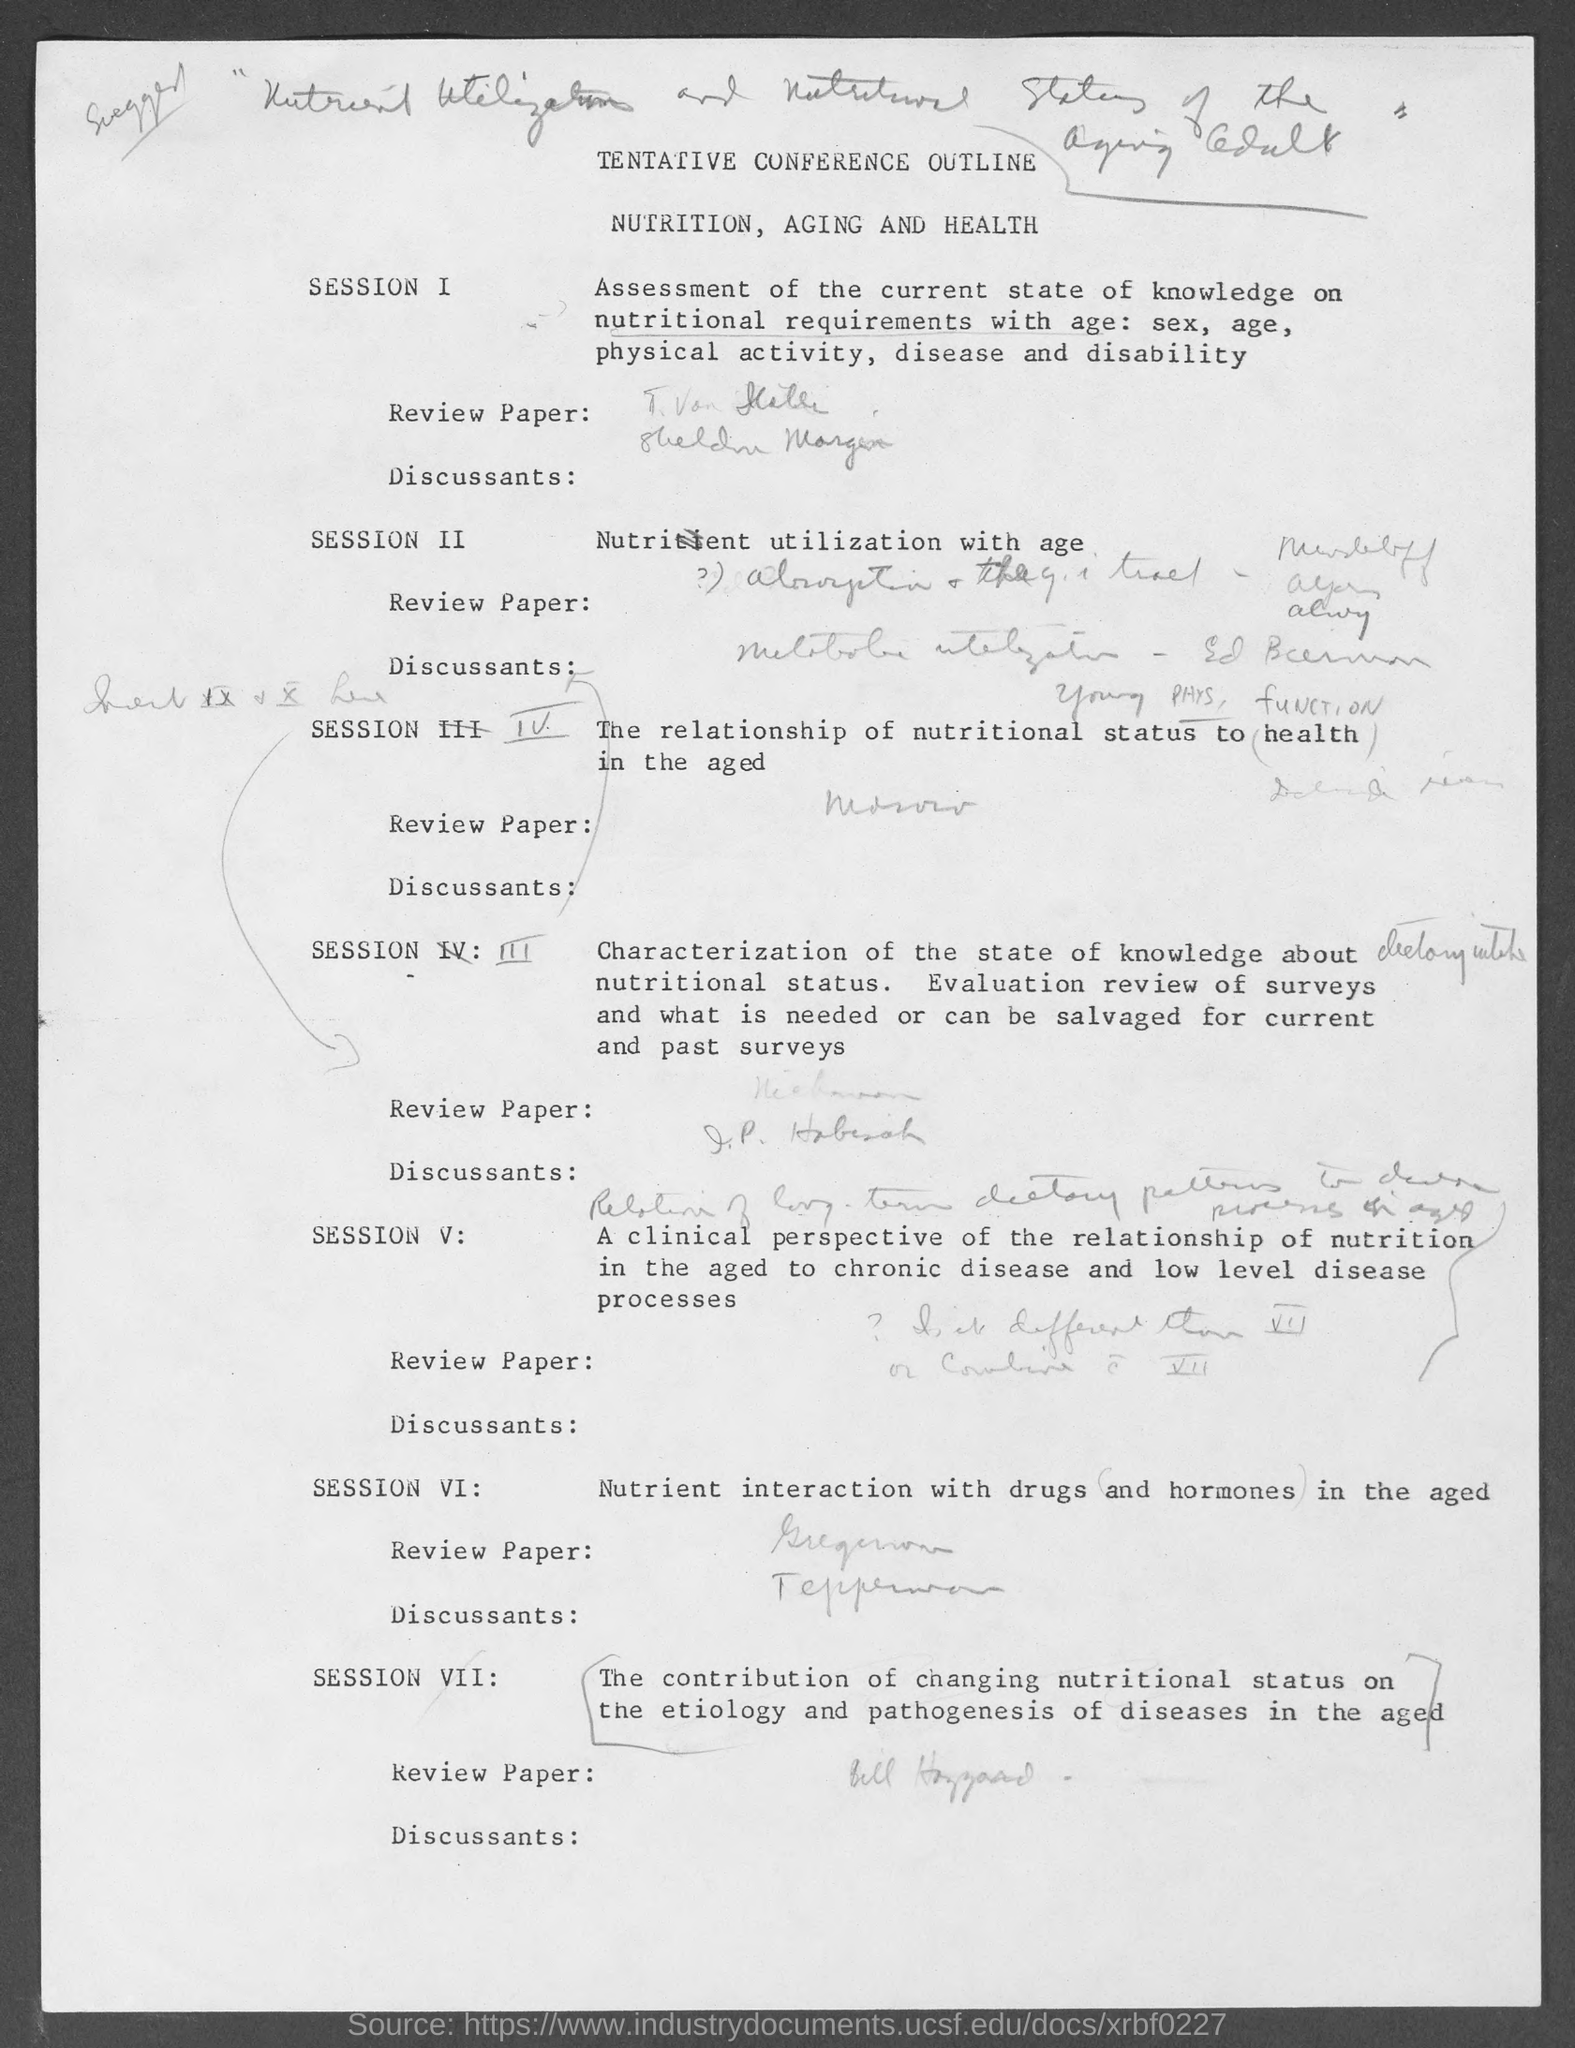What does session ii deals with?
Your response must be concise. NUTRITIENT UTILIZATION WITH AGE. 